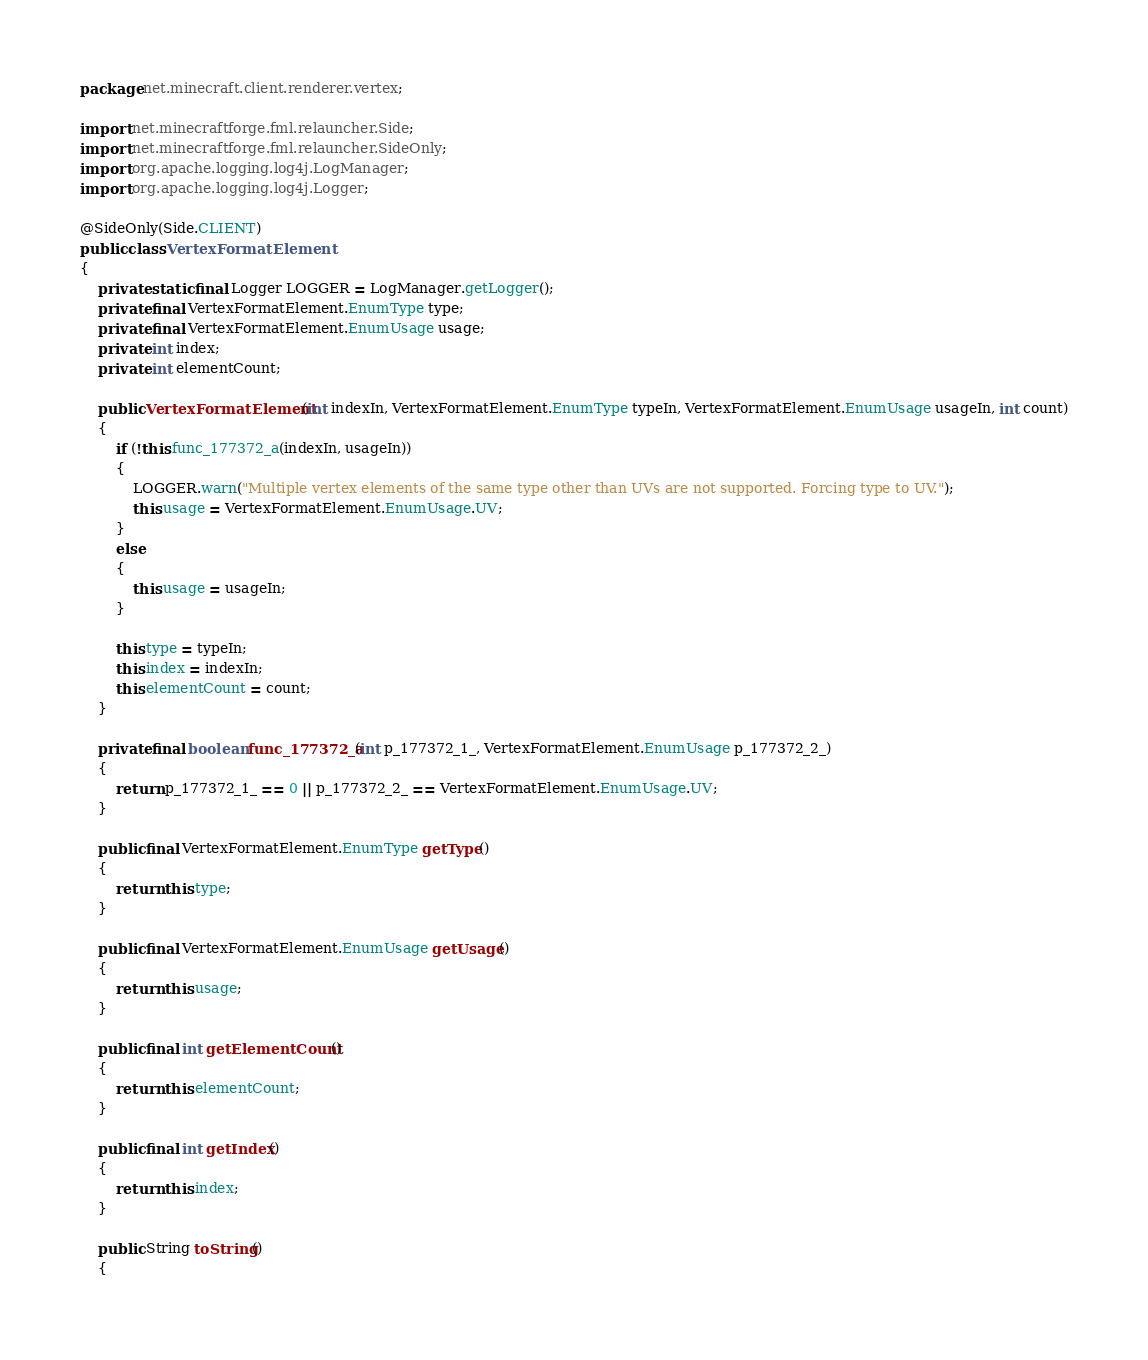Convert code to text. <code><loc_0><loc_0><loc_500><loc_500><_Java_>package net.minecraft.client.renderer.vertex;

import net.minecraftforge.fml.relauncher.Side;
import net.minecraftforge.fml.relauncher.SideOnly;
import org.apache.logging.log4j.LogManager;
import org.apache.logging.log4j.Logger;

@SideOnly(Side.CLIENT)
public class VertexFormatElement
{
    private static final Logger LOGGER = LogManager.getLogger();
    private final VertexFormatElement.EnumType type;
    private final VertexFormatElement.EnumUsage usage;
    private int index;
    private int elementCount;

    public VertexFormatElement(int indexIn, VertexFormatElement.EnumType typeIn, VertexFormatElement.EnumUsage usageIn, int count)
    {
        if (!this.func_177372_a(indexIn, usageIn))
        {
            LOGGER.warn("Multiple vertex elements of the same type other than UVs are not supported. Forcing type to UV.");
            this.usage = VertexFormatElement.EnumUsage.UV;
        }
        else
        {
            this.usage = usageIn;
        }

        this.type = typeIn;
        this.index = indexIn;
        this.elementCount = count;
    }

    private final boolean func_177372_a(int p_177372_1_, VertexFormatElement.EnumUsage p_177372_2_)
    {
        return p_177372_1_ == 0 || p_177372_2_ == VertexFormatElement.EnumUsage.UV;
    }

    public final VertexFormatElement.EnumType getType()
    {
        return this.type;
    }

    public final VertexFormatElement.EnumUsage getUsage()
    {
        return this.usage;
    }

    public final int getElementCount()
    {
        return this.elementCount;
    }

    public final int getIndex()
    {
        return this.index;
    }

    public String toString()
    {</code> 